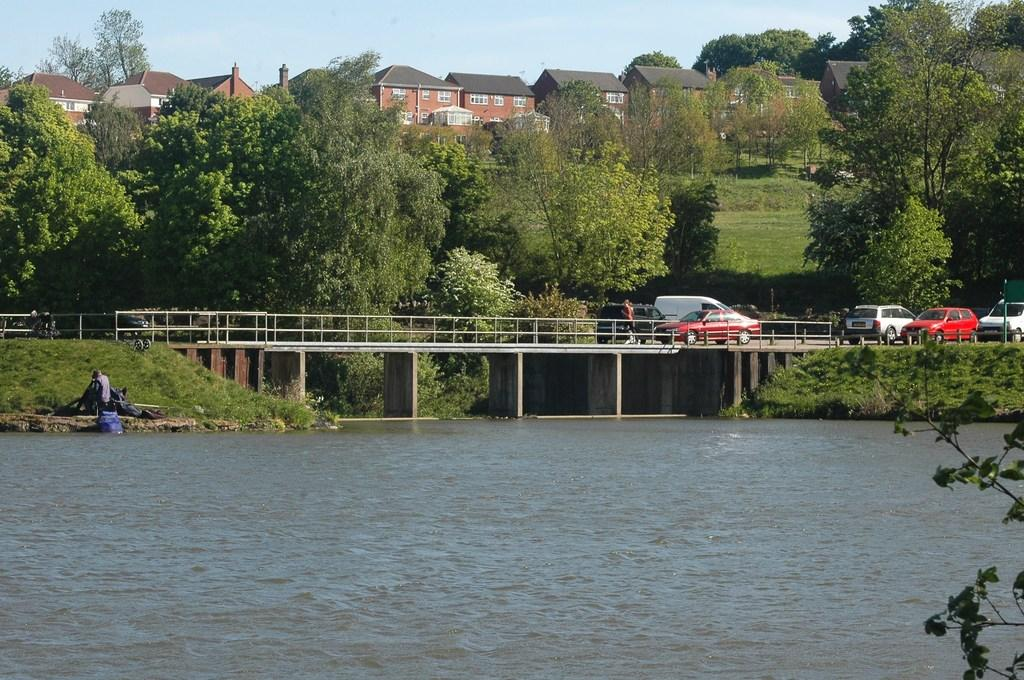What is happening on the bridge in the image? There are vehicles on a bridge in the image. What type of natural environment can be seen in the image? Trees are visible in the image, and there is a river under the bridge. What type of structures are present in the image? Houses are present in the image. What is the condition of the sky in the image? The sky is blue in the image. What can be found near the river in the image? Grass and rocks are present near the river. What type of meal is being served to the queen in the image? There is no queen or meal present in the image. Can you point out the map in the image? There is no map present in the image. 